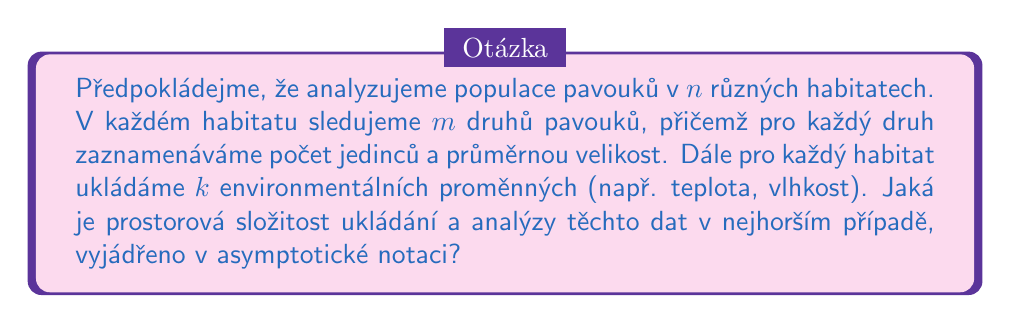Can you answer this question? Pro řešení této úlohy postupujeme následovně:

1. Nejprve identifikujeme všechny proměnné, které potřebujeme uložit:
   - $n$: počet habitatů
   - $m$: počet druhů pavouků v každém habitatu
   - Pro každý druh pavouků ukládáme 2 hodnoty (počet jedinců a průměrnou velikost)
   - $k$: počet environmentálních proměnných pro každý habitat

2. Vypočítáme potřebný prostor:
   - Pro data o pavoučích druzích: $n \cdot m \cdot 2$
   - Pro environmentální proměnné: $n \cdot k$

3. Celková prostorová složitost je součtem těchto dvou částí:
   $$S(n,m,k) = n \cdot m \cdot 2 + n \cdot k$$

4. Zjednodušíme výraz:
   $$S(n,m,k) = 2nm + nk = n(2m + k)$$

5. V asymptotické notaci se zaměřujeme na dominantní členy při rostoucích hodnotách proměnných. Vzhledem k tomu, že všechny proměnné ($n$, $m$, $k$) mohou růst nezávisle, nemůžeme žádnou z nich zanedbat.

6. Proto je výsledná prostorová složitost v nejhorším případě:
   $$O(nmk)$$

Tato notace zahrnuje všechny možné scénáře růstu proměnných a poskytuje horní mez pro prostorovou složitost.
Answer: $O(nmk)$ 